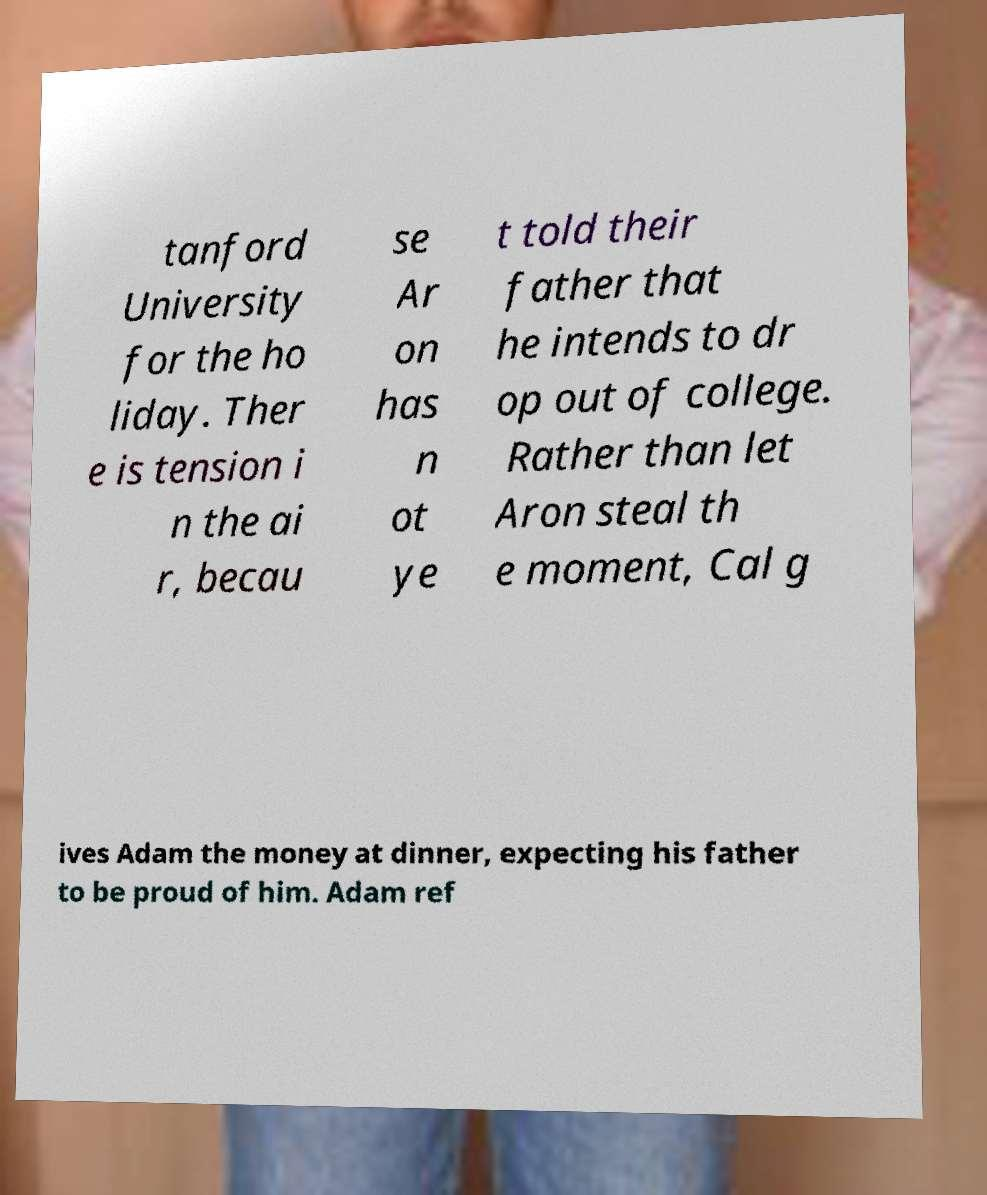There's text embedded in this image that I need extracted. Can you transcribe it verbatim? tanford University for the ho liday. Ther e is tension i n the ai r, becau se Ar on has n ot ye t told their father that he intends to dr op out of college. Rather than let Aron steal th e moment, Cal g ives Adam the money at dinner, expecting his father to be proud of him. Adam ref 